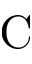<formula> <loc_0><loc_0><loc_500><loc_500>C</formula> 